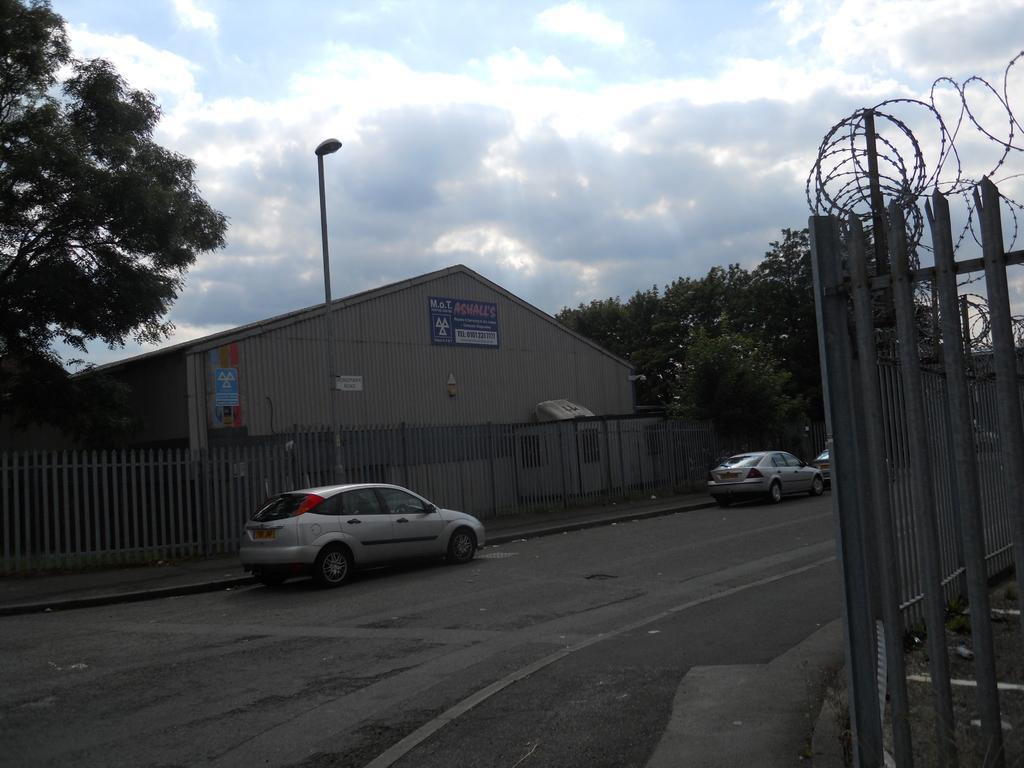How would you summarize this image in a sentence or two? As we can see in the image there is a house, fence, cars, trees, street lamp, sky and clouds. 